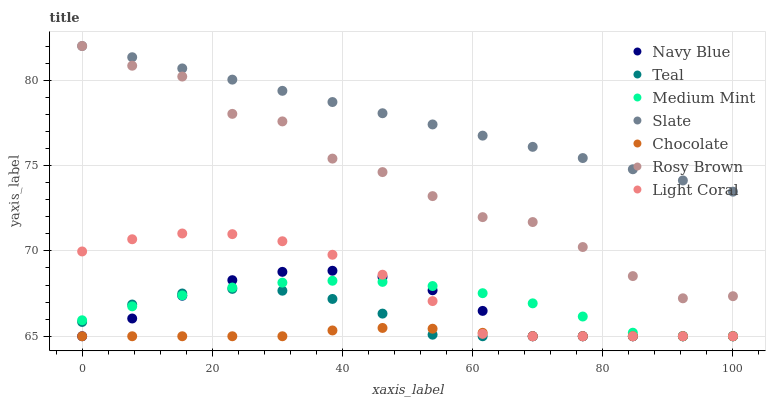Does Chocolate have the minimum area under the curve?
Answer yes or no. Yes. Does Slate have the maximum area under the curve?
Answer yes or no. Yes. Does Navy Blue have the minimum area under the curve?
Answer yes or no. No. Does Navy Blue have the maximum area under the curve?
Answer yes or no. No. Is Slate the smoothest?
Answer yes or no. Yes. Is Rosy Brown the roughest?
Answer yes or no. Yes. Is Navy Blue the smoothest?
Answer yes or no. No. Is Navy Blue the roughest?
Answer yes or no. No. Does Medium Mint have the lowest value?
Answer yes or no. Yes. Does Slate have the lowest value?
Answer yes or no. No. Does Rosy Brown have the highest value?
Answer yes or no. Yes. Does Navy Blue have the highest value?
Answer yes or no. No. Is Navy Blue less than Slate?
Answer yes or no. Yes. Is Rosy Brown greater than Navy Blue?
Answer yes or no. Yes. Does Rosy Brown intersect Slate?
Answer yes or no. Yes. Is Rosy Brown less than Slate?
Answer yes or no. No. Is Rosy Brown greater than Slate?
Answer yes or no. No. Does Navy Blue intersect Slate?
Answer yes or no. No. 